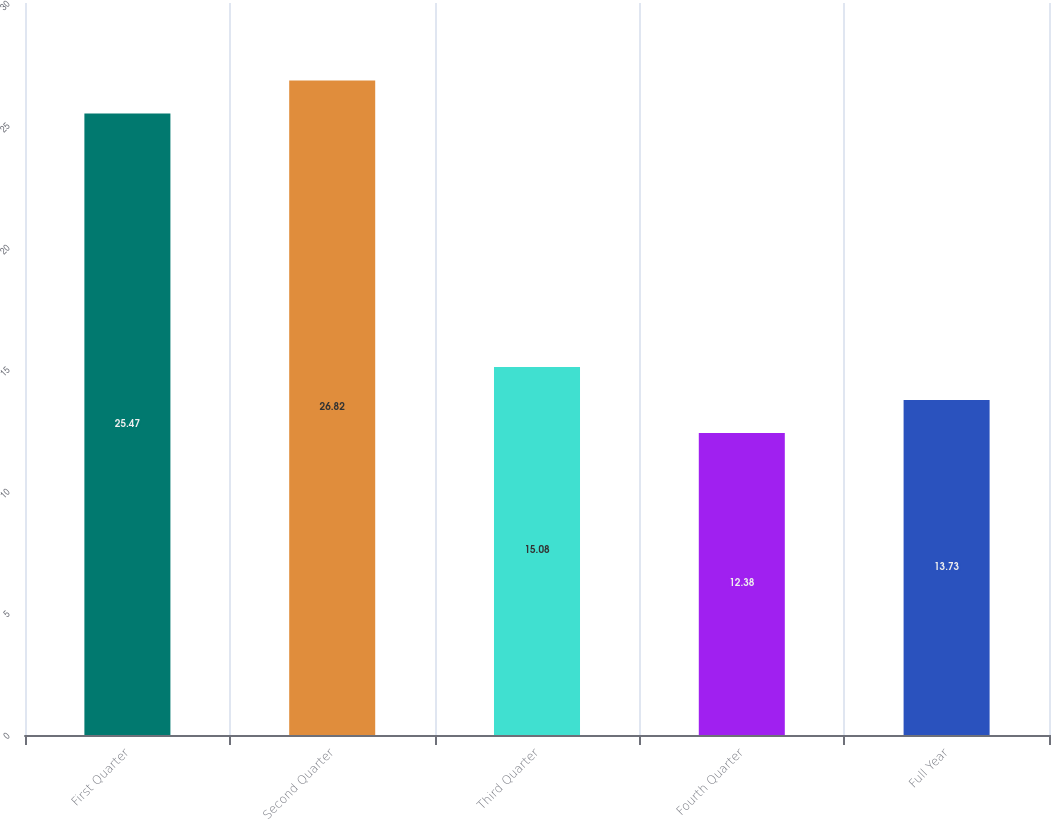Convert chart. <chart><loc_0><loc_0><loc_500><loc_500><bar_chart><fcel>First Quarter<fcel>Second Quarter<fcel>Third Quarter<fcel>Fourth Quarter<fcel>Full Year<nl><fcel>25.47<fcel>26.82<fcel>15.08<fcel>12.38<fcel>13.73<nl></chart> 